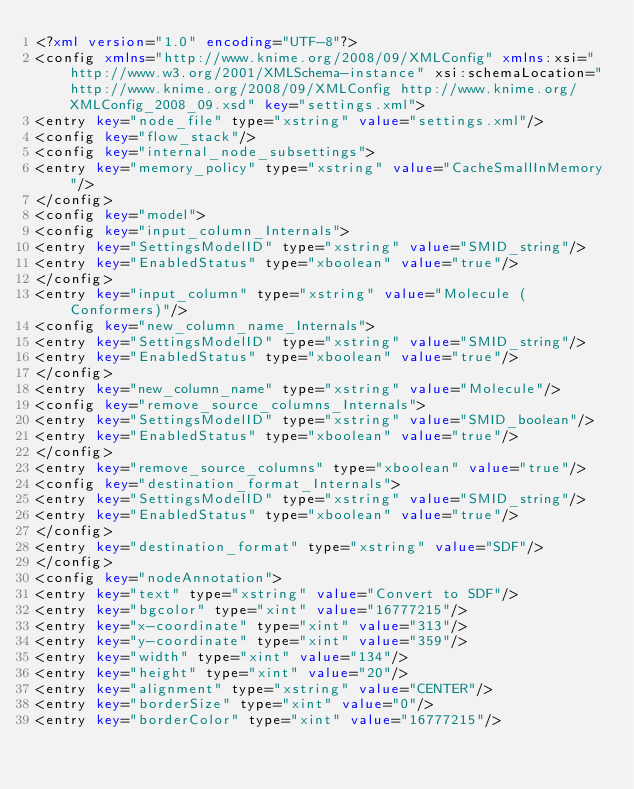Convert code to text. <code><loc_0><loc_0><loc_500><loc_500><_XML_><?xml version="1.0" encoding="UTF-8"?>
<config xmlns="http://www.knime.org/2008/09/XMLConfig" xmlns:xsi="http://www.w3.org/2001/XMLSchema-instance" xsi:schemaLocation="http://www.knime.org/2008/09/XMLConfig http://www.knime.org/XMLConfig_2008_09.xsd" key="settings.xml">
<entry key="node_file" type="xstring" value="settings.xml"/>
<config key="flow_stack"/>
<config key="internal_node_subsettings">
<entry key="memory_policy" type="xstring" value="CacheSmallInMemory"/>
</config>
<config key="model">
<config key="input_column_Internals">
<entry key="SettingsModelID" type="xstring" value="SMID_string"/>
<entry key="EnabledStatus" type="xboolean" value="true"/>
</config>
<entry key="input_column" type="xstring" value="Molecule (Conformers)"/>
<config key="new_column_name_Internals">
<entry key="SettingsModelID" type="xstring" value="SMID_string"/>
<entry key="EnabledStatus" type="xboolean" value="true"/>
</config>
<entry key="new_column_name" type="xstring" value="Molecule"/>
<config key="remove_source_columns_Internals">
<entry key="SettingsModelID" type="xstring" value="SMID_boolean"/>
<entry key="EnabledStatus" type="xboolean" value="true"/>
</config>
<entry key="remove_source_columns" type="xboolean" value="true"/>
<config key="destination_format_Internals">
<entry key="SettingsModelID" type="xstring" value="SMID_string"/>
<entry key="EnabledStatus" type="xboolean" value="true"/>
</config>
<entry key="destination_format" type="xstring" value="SDF"/>
</config>
<config key="nodeAnnotation">
<entry key="text" type="xstring" value="Convert to SDF"/>
<entry key="bgcolor" type="xint" value="16777215"/>
<entry key="x-coordinate" type="xint" value="313"/>
<entry key="y-coordinate" type="xint" value="359"/>
<entry key="width" type="xint" value="134"/>
<entry key="height" type="xint" value="20"/>
<entry key="alignment" type="xstring" value="CENTER"/>
<entry key="borderSize" type="xint" value="0"/>
<entry key="borderColor" type="xint" value="16777215"/></code> 